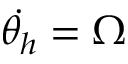<formula> <loc_0><loc_0><loc_500><loc_500>\dot { \theta _ { h } } = \Omega</formula> 